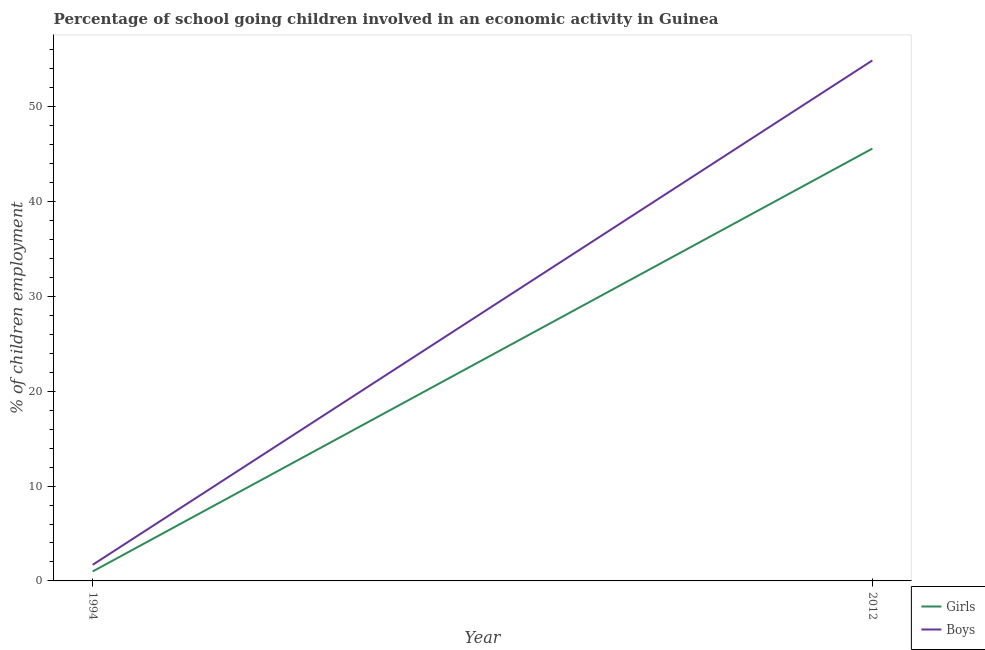How many different coloured lines are there?
Provide a short and direct response. 2. Does the line corresponding to percentage of school going girls intersect with the line corresponding to percentage of school going boys?
Offer a terse response. No. Is the number of lines equal to the number of legend labels?
Your answer should be very brief. Yes. What is the percentage of school going girls in 1994?
Keep it short and to the point. 1. Across all years, what is the maximum percentage of school going boys?
Offer a terse response. 54.9. In which year was the percentage of school going boys maximum?
Your answer should be very brief. 2012. In which year was the percentage of school going girls minimum?
Make the answer very short. 1994. What is the total percentage of school going girls in the graph?
Offer a very short reply. 46.6. What is the difference between the percentage of school going boys in 1994 and that in 2012?
Keep it short and to the point. -53.2. What is the difference between the percentage of school going girls in 1994 and the percentage of school going boys in 2012?
Offer a terse response. -53.9. What is the average percentage of school going boys per year?
Provide a short and direct response. 28.3. In the year 2012, what is the difference between the percentage of school going girls and percentage of school going boys?
Your answer should be compact. -9.3. In how many years, is the percentage of school going girls greater than 20 %?
Give a very brief answer. 1. What is the ratio of the percentage of school going boys in 1994 to that in 2012?
Provide a succinct answer. 0.03. Is the percentage of school going girls in 1994 less than that in 2012?
Provide a succinct answer. Yes. Does the percentage of school going girls monotonically increase over the years?
Keep it short and to the point. Yes. Is the percentage of school going girls strictly greater than the percentage of school going boys over the years?
Offer a very short reply. No. Is the percentage of school going boys strictly less than the percentage of school going girls over the years?
Ensure brevity in your answer.  No. How many lines are there?
Give a very brief answer. 2. How many years are there in the graph?
Provide a short and direct response. 2. What is the difference between two consecutive major ticks on the Y-axis?
Make the answer very short. 10. Does the graph contain grids?
Ensure brevity in your answer.  No. How are the legend labels stacked?
Your answer should be very brief. Vertical. What is the title of the graph?
Make the answer very short. Percentage of school going children involved in an economic activity in Guinea. Does "Boys" appear as one of the legend labels in the graph?
Provide a short and direct response. Yes. What is the label or title of the Y-axis?
Ensure brevity in your answer.  % of children employment. What is the % of children employment of Girls in 1994?
Offer a terse response. 1. What is the % of children employment in Boys in 1994?
Your response must be concise. 1.7. What is the % of children employment in Girls in 2012?
Ensure brevity in your answer.  45.6. What is the % of children employment of Boys in 2012?
Make the answer very short. 54.9. Across all years, what is the maximum % of children employment in Girls?
Make the answer very short. 45.6. Across all years, what is the maximum % of children employment in Boys?
Make the answer very short. 54.9. Across all years, what is the minimum % of children employment of Girls?
Your response must be concise. 1. Across all years, what is the minimum % of children employment in Boys?
Offer a terse response. 1.7. What is the total % of children employment of Girls in the graph?
Your response must be concise. 46.6. What is the total % of children employment of Boys in the graph?
Provide a short and direct response. 56.6. What is the difference between the % of children employment in Girls in 1994 and that in 2012?
Provide a succinct answer. -44.6. What is the difference between the % of children employment of Boys in 1994 and that in 2012?
Give a very brief answer. -53.2. What is the difference between the % of children employment of Girls in 1994 and the % of children employment of Boys in 2012?
Provide a short and direct response. -53.9. What is the average % of children employment in Girls per year?
Offer a very short reply. 23.3. What is the average % of children employment in Boys per year?
Offer a very short reply. 28.3. What is the ratio of the % of children employment of Girls in 1994 to that in 2012?
Provide a succinct answer. 0.02. What is the ratio of the % of children employment of Boys in 1994 to that in 2012?
Your answer should be very brief. 0.03. What is the difference between the highest and the second highest % of children employment of Girls?
Your response must be concise. 44.6. What is the difference between the highest and the second highest % of children employment in Boys?
Provide a succinct answer. 53.2. What is the difference between the highest and the lowest % of children employment in Girls?
Offer a terse response. 44.6. What is the difference between the highest and the lowest % of children employment of Boys?
Offer a very short reply. 53.2. 